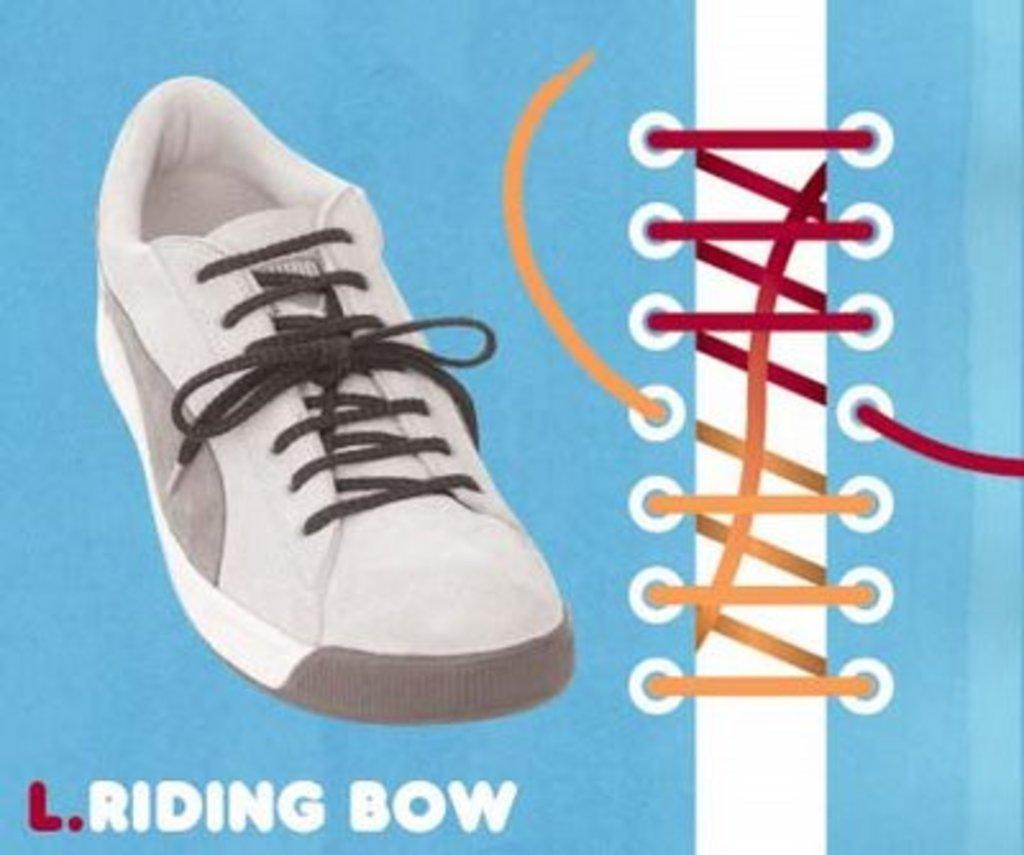What type of visual representation is the image? The image is a poster. What object is featured in the poster? There is a shoe in the poster. What design element is present on the right side of the poster? There is a picture of yellow and red colored lace on the right side of the poster. Where is the text located in the poster? There is text at the bottom of the poster. What type of slope can be seen in the image? There is no slope present in the image; it is a poster featuring a shoe and colored lace. Is there any paint visible on the stranger in the image? There is no stranger present in the image; it is a poster with a shoe, colored lace, and text. 